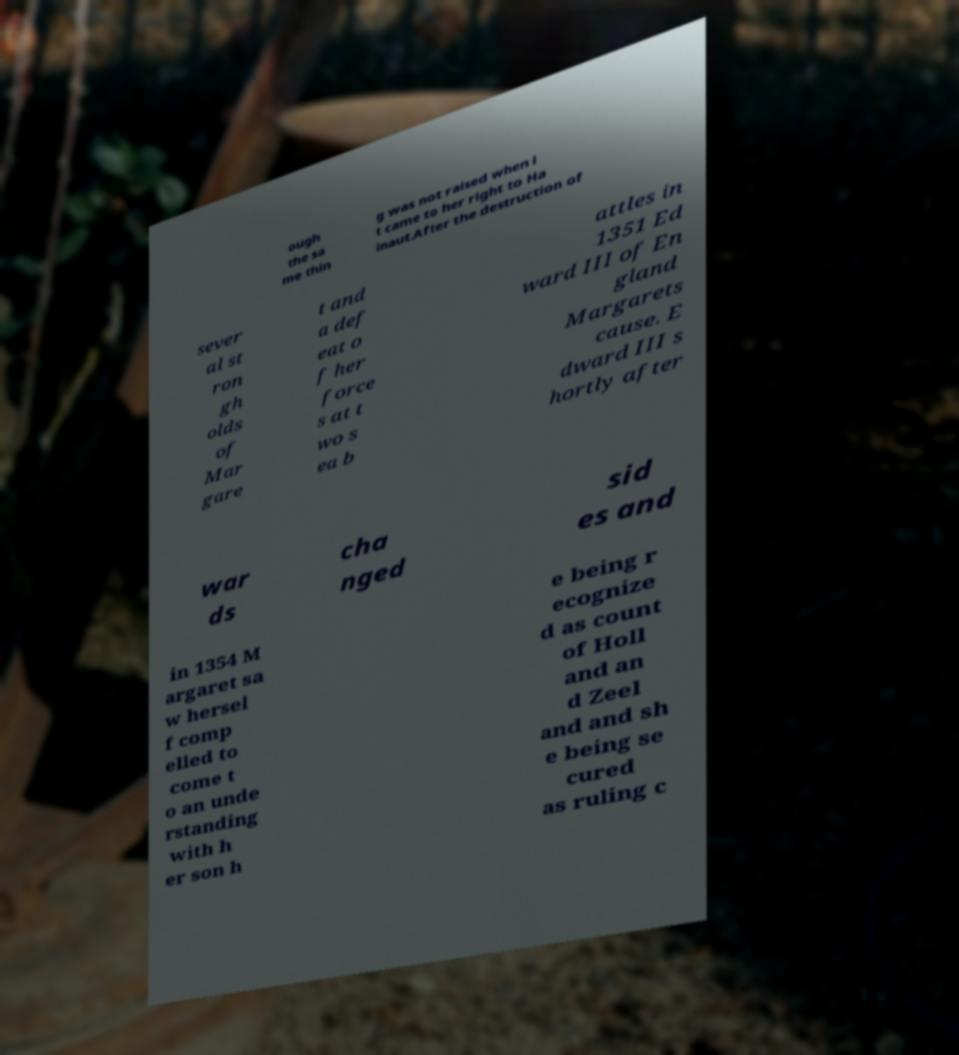There's text embedded in this image that I need extracted. Can you transcribe it verbatim? ough the sa me thin g was not raised when i t came to her right to Ha inaut.After the destruction of sever al st ron gh olds of Mar gare t and a def eat o f her force s at t wo s ea b attles in 1351 Ed ward III of En gland Margarets cause. E dward III s hortly after war ds cha nged sid es and in 1354 M argaret sa w hersel f comp elled to come t o an unde rstanding with h er son h e being r ecognize d as count of Holl and an d Zeel and and sh e being se cured as ruling c 